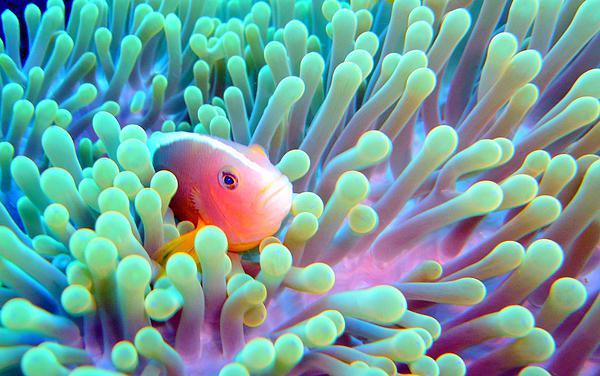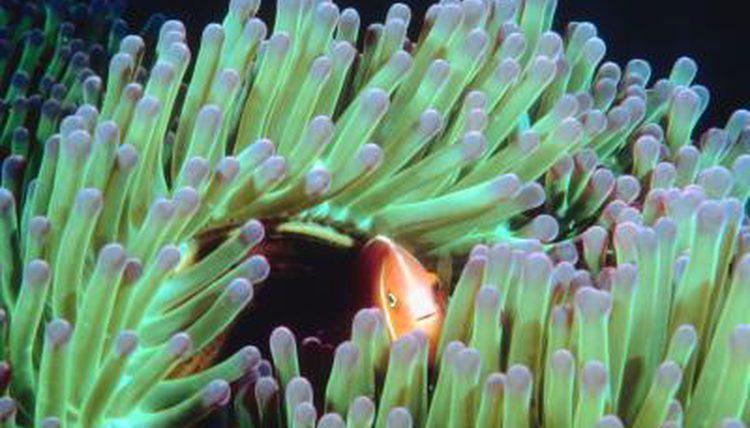The first image is the image on the left, the second image is the image on the right. For the images displayed, is the sentence "An image shows an orange fish swimming amid green anemone tendrils, and the image contains multiple fish." factually correct? Answer yes or no. No. The first image is the image on the left, the second image is the image on the right. Analyze the images presented: Is the assertion "There are two or fewer fish across both images." valid? Answer yes or no. Yes. 